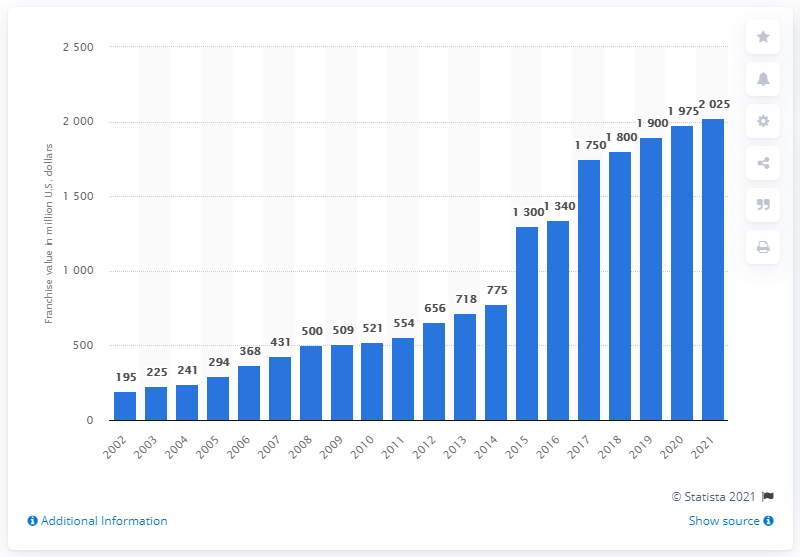Give some essential details in this illustration. The estimated value of the Los Angeles Angels in 2021 was. 